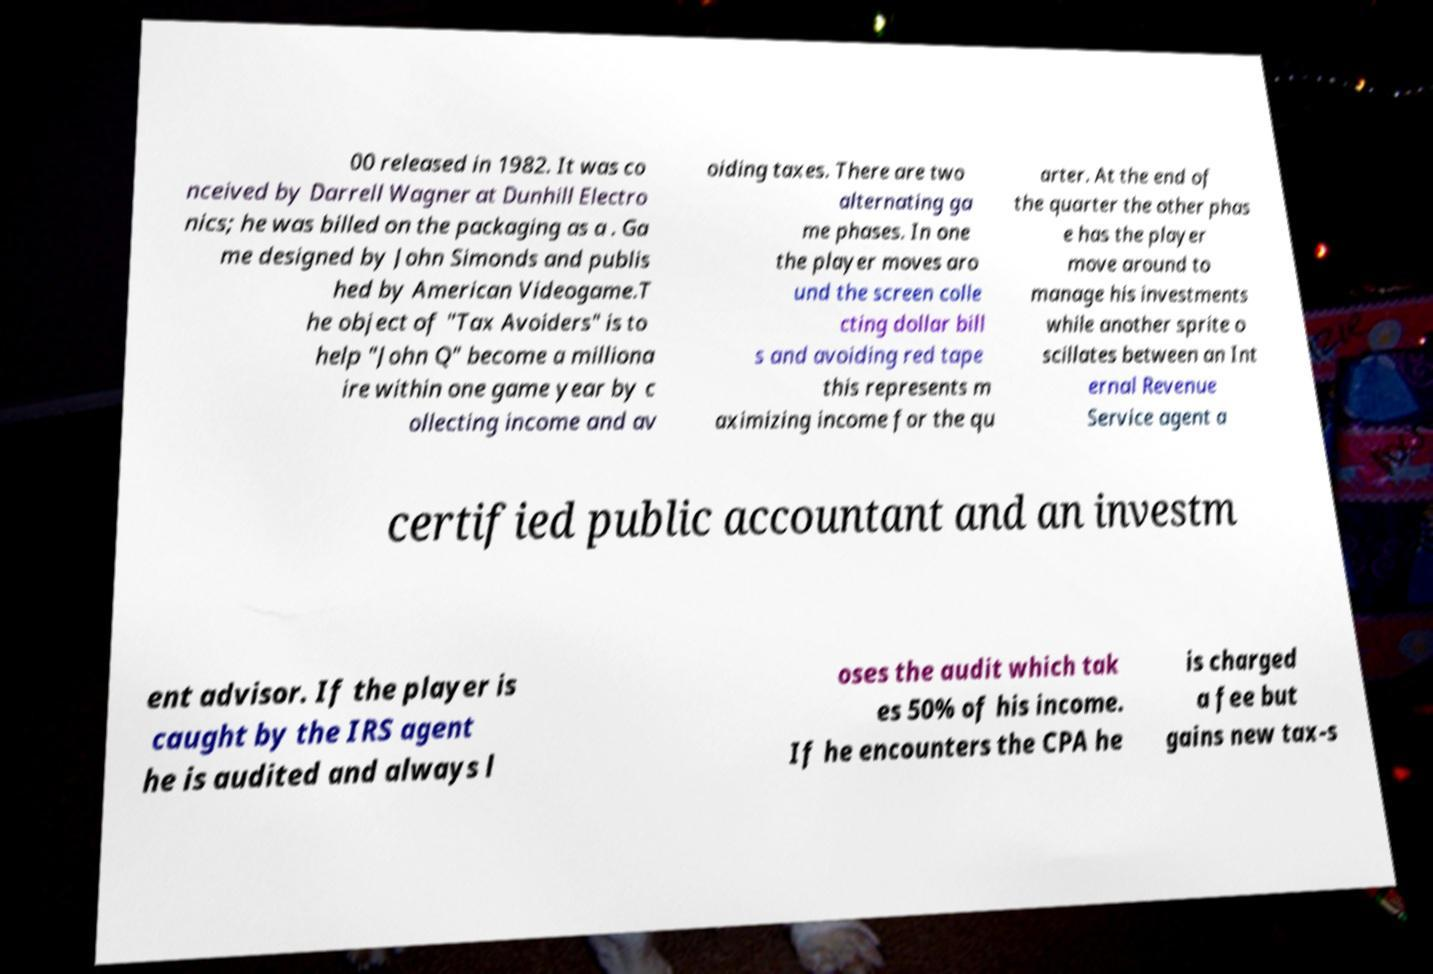Can you read and provide the text displayed in the image?This photo seems to have some interesting text. Can you extract and type it out for me? 00 released in 1982. It was co nceived by Darrell Wagner at Dunhill Electro nics; he was billed on the packaging as a . Ga me designed by John Simonds and publis hed by American Videogame.T he object of "Tax Avoiders" is to help "John Q" become a milliona ire within one game year by c ollecting income and av oiding taxes. There are two alternating ga me phases. In one the player moves aro und the screen colle cting dollar bill s and avoiding red tape this represents m aximizing income for the qu arter. At the end of the quarter the other phas e has the player move around to manage his investments while another sprite o scillates between an Int ernal Revenue Service agent a certified public accountant and an investm ent advisor. If the player is caught by the IRS agent he is audited and always l oses the audit which tak es 50% of his income. If he encounters the CPA he is charged a fee but gains new tax-s 